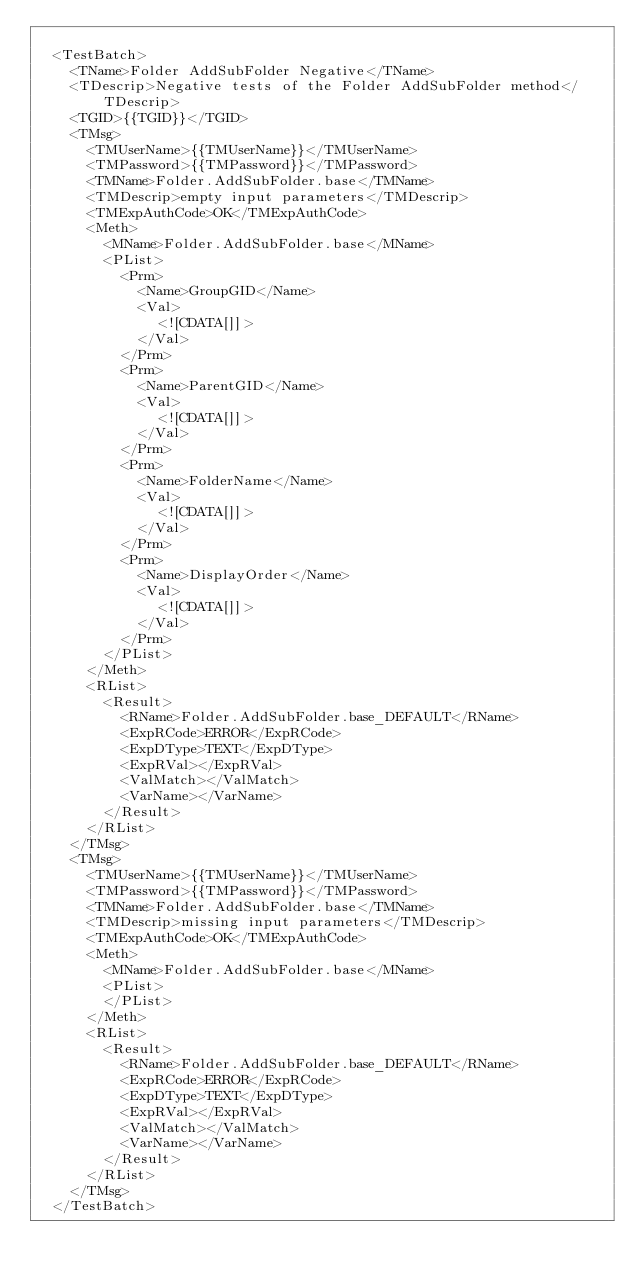Convert code to text. <code><loc_0><loc_0><loc_500><loc_500><_XML_>
	<TestBatch>
		<TName>Folder AddSubFolder Negative</TName>
		<TDescrip>Negative tests of the Folder AddSubFolder method</TDescrip>
		<TGID>{{TGID}}</TGID>
		<TMsg>
			<TMUserName>{{TMUserName}}</TMUserName>
			<TMPassword>{{TMPassword}}</TMPassword>
			<TMName>Folder.AddSubFolder.base</TMName>
			<TMDescrip>empty input parameters</TMDescrip>
			<TMExpAuthCode>OK</TMExpAuthCode>
			<Meth>
				<MName>Folder.AddSubFolder.base</MName>
				<PList>
					<Prm>
						<Name>GroupGID</Name>
						<Val>
							<![CDATA[]]>
						</Val>
					</Prm>
					<Prm>
						<Name>ParentGID</Name>
						<Val>
							<![CDATA[]]>
						</Val>
					</Prm>
					<Prm>
						<Name>FolderName</Name>
						<Val>
							<![CDATA[]]>
						</Val>
					</Prm>
					<Prm>
						<Name>DisplayOrder</Name>
						<Val>
							<![CDATA[]]>
						</Val>
					</Prm>
				</PList>
			</Meth>
			<RList>
				<Result>
					<RName>Folder.AddSubFolder.base_DEFAULT</RName>
					<ExpRCode>ERROR</ExpRCode>
					<ExpDType>TEXT</ExpDType>
					<ExpRVal></ExpRVal>
					<ValMatch></ValMatch>
					<VarName></VarName>
				</Result>
			</RList>
		</TMsg>
		<TMsg>
			<TMUserName>{{TMUserName}}</TMUserName>
			<TMPassword>{{TMPassword}}</TMPassword>
			<TMName>Folder.AddSubFolder.base</TMName>
			<TMDescrip>missing input parameters</TMDescrip>
			<TMExpAuthCode>OK</TMExpAuthCode>
			<Meth>
				<MName>Folder.AddSubFolder.base</MName>
				<PList>
				</PList>
			</Meth>
			<RList>
				<Result>
					<RName>Folder.AddSubFolder.base_DEFAULT</RName>
					<ExpRCode>ERROR</ExpRCode>
					<ExpDType>TEXT</ExpDType>
					<ExpRVal></ExpRVal>
					<ValMatch></ValMatch>
					<VarName></VarName>
				</Result>
			</RList>
		</TMsg>
	</TestBatch>
	</code> 